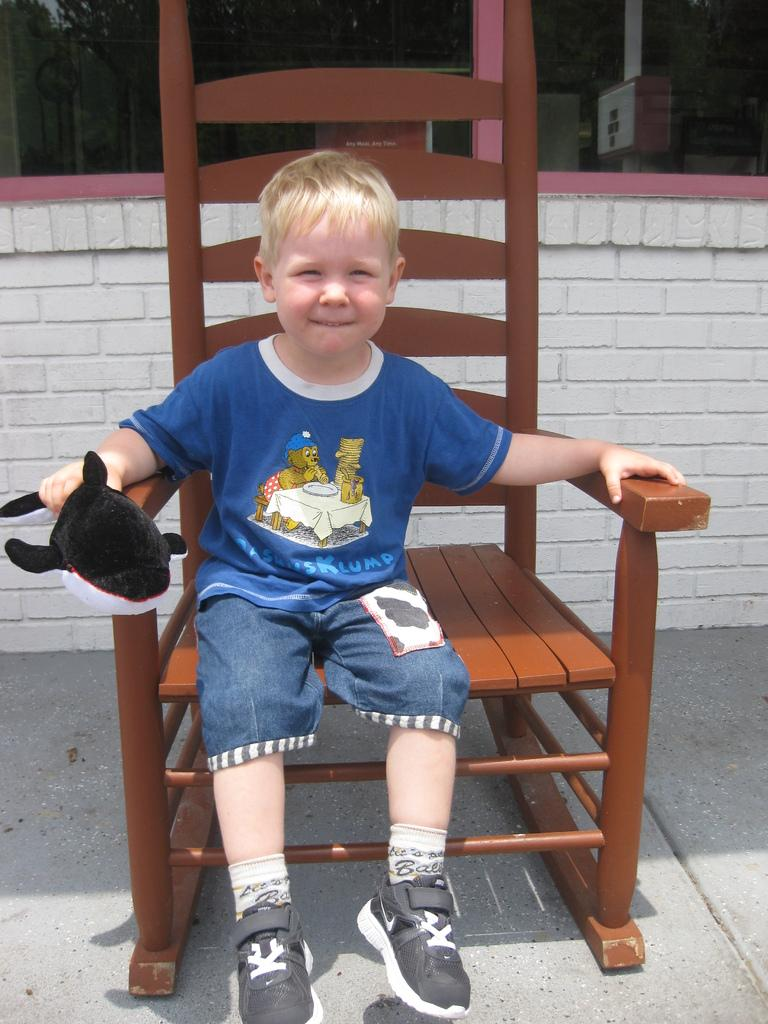What is the boy in the image doing? The boy is sitting on a chair in the image. What is the boy holding in his hand? The boy is holding a doll in his hand. What can be seen in the background of the image? There is a pole and a wall with bricks in the background of the image. What type of beef is being served on the sofa in the image? There is no sofa or beef present in the image. 